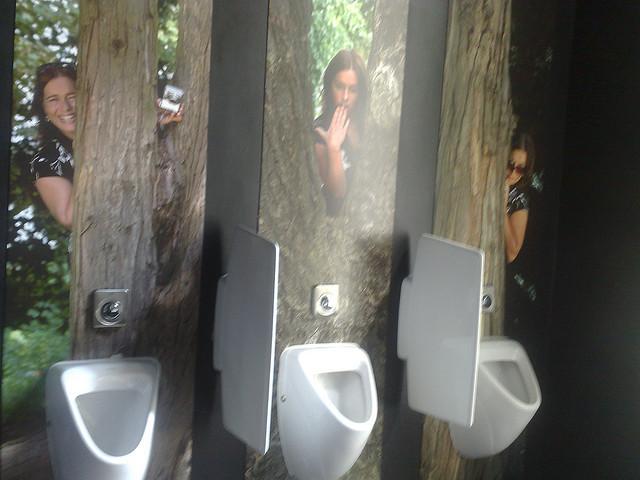Are the people in this picture real?
Quick response, please. No. Was this picture taken outside?
Give a very brief answer. No. Is this the ladies room?
Write a very short answer. No. 